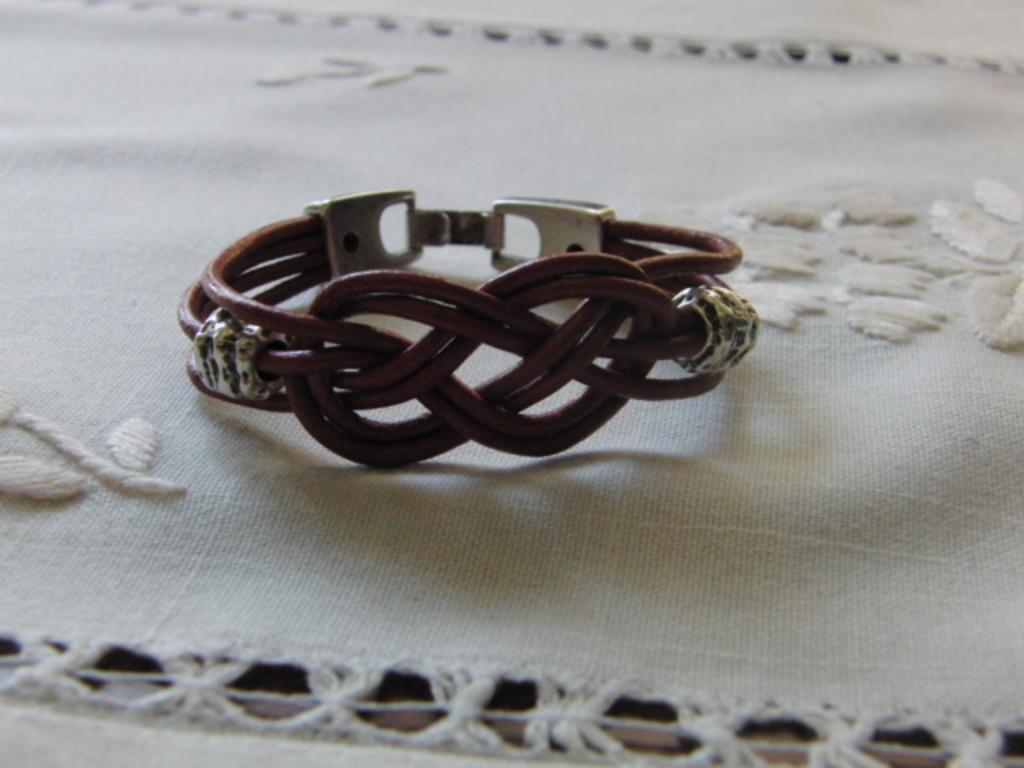What is the main object in the image? There is a black rubber band in the image. Is there anything attached to the rubber band? Yes, there is a clip attached to the rubber band. Where are the rubber band and clip placed? They are placed on a white cloth. Can you describe the white cloth? The white cloth has designs on it. How many divisions can be seen in the feast depicted in the image? There is no feast depicted in the image; it features a black rubber band, a clip, and a white cloth with designs. Can you describe the bee buzzing around the rubber band in the image? There is no bee present in the image. 